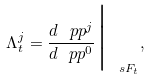<formula> <loc_0><loc_0><loc_500><loc_500>\Lambda ^ { j } _ { t } = \frac { d \ p p ^ { j } } { d \ p p ^ { 0 } } \Big | _ { \ s F _ { t } } ,</formula> 